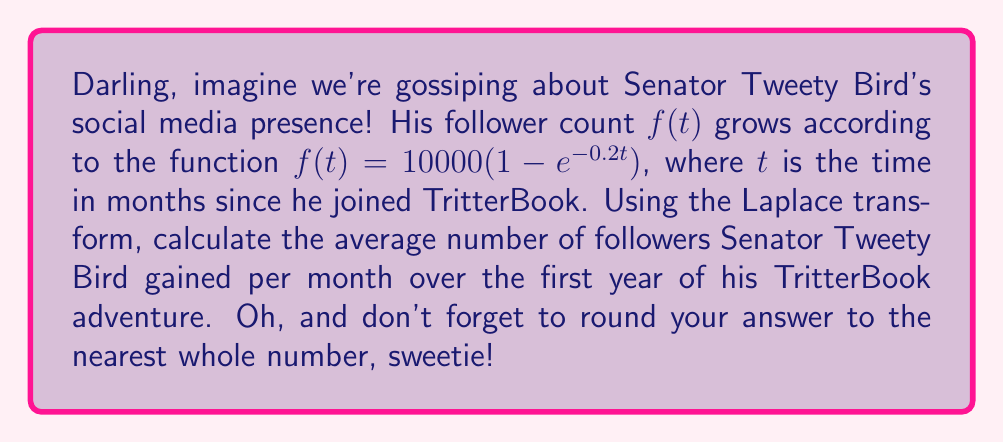Could you help me with this problem? Let's break this down step-by-step, dearie:

1) First, we need to find the Laplace transform of $f(t)$. Let's call it $F(s)$:

   $$F(s) = \mathcal{L}\{f(t)\} = \mathcal{L}\{10000(1 - e^{-0.2t})\}$$

2) Using Laplace transform properties:

   $$F(s) = \frac{10000}{s} - \frac{10000}{s+0.2}$$

3) To find the average over the first year, we need to use the Final Value Theorem:

   $$\lim_{t \to \infty} \frac{1}{T}\int_0^T f(t)dt = \lim_{s \to 0} sF(s)$$

   Where $T = 12$ months.

4) Let's calculate $\lim_{s \to 0} sF(s)$:

   $$\lim_{s \to 0} s(\frac{10000}{s} - \frac{10000}{s+0.2})$$
   $$= \lim_{s \to 0} (10000 - \frac{10000s}{s+0.2})$$
   $$= 10000 - 0 = 10000$$

5) This means that over a very long time, the average follower count approaches 10000.

6) But we want the average over just the first year. We can approximate this by taking the average of the initial value (0) and the value at 12 months:

   $$f(12) = 10000(1 - e^{-0.2*12}) \approx 9084$$

7) So the average over the first year is approximately:

   $$\frac{0 + 9084}{2} = 4542$$

8) Rounding to the nearest whole number gives us 4542.
Answer: 4542 followers 